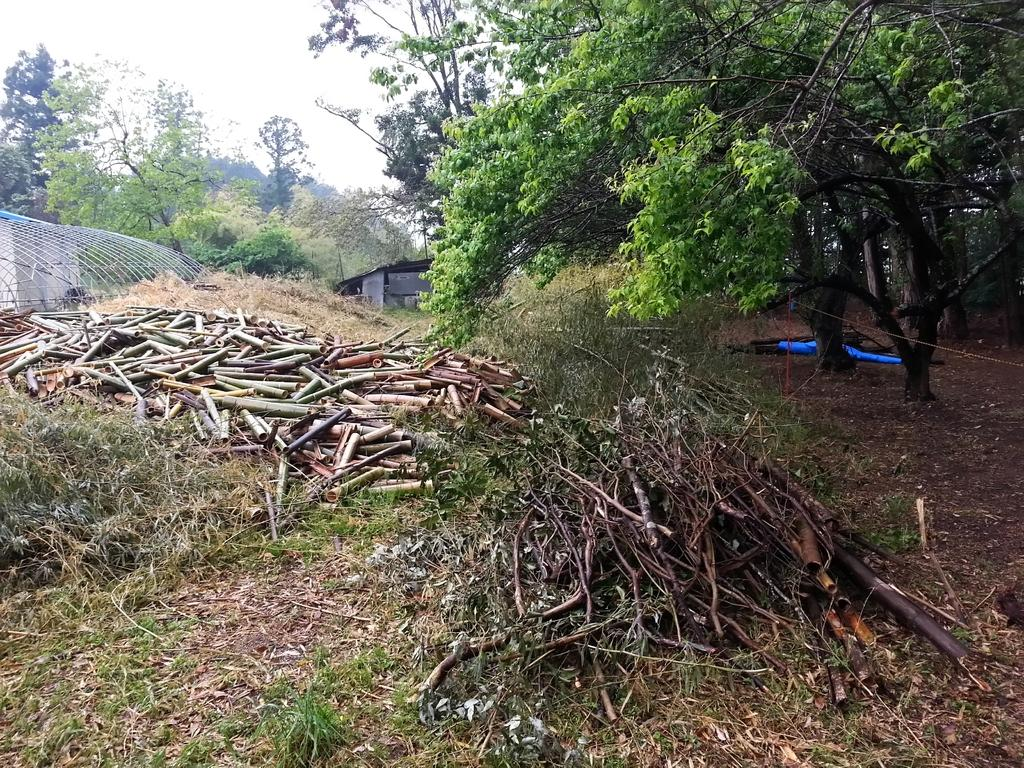What type of vegetation can be seen in the image? There are trees, sticks, and leaves in the image. What is on the ground in the image? There is grass on the ground in the image. What can be seen in the background of the image? There are objects visible in the background of the image, and the sky is also visible. What was the experience of the week like for the leaves in the image? There is no indication of any experience or time frame for the leaves in the image; they are simply depicted as part of the scene. 